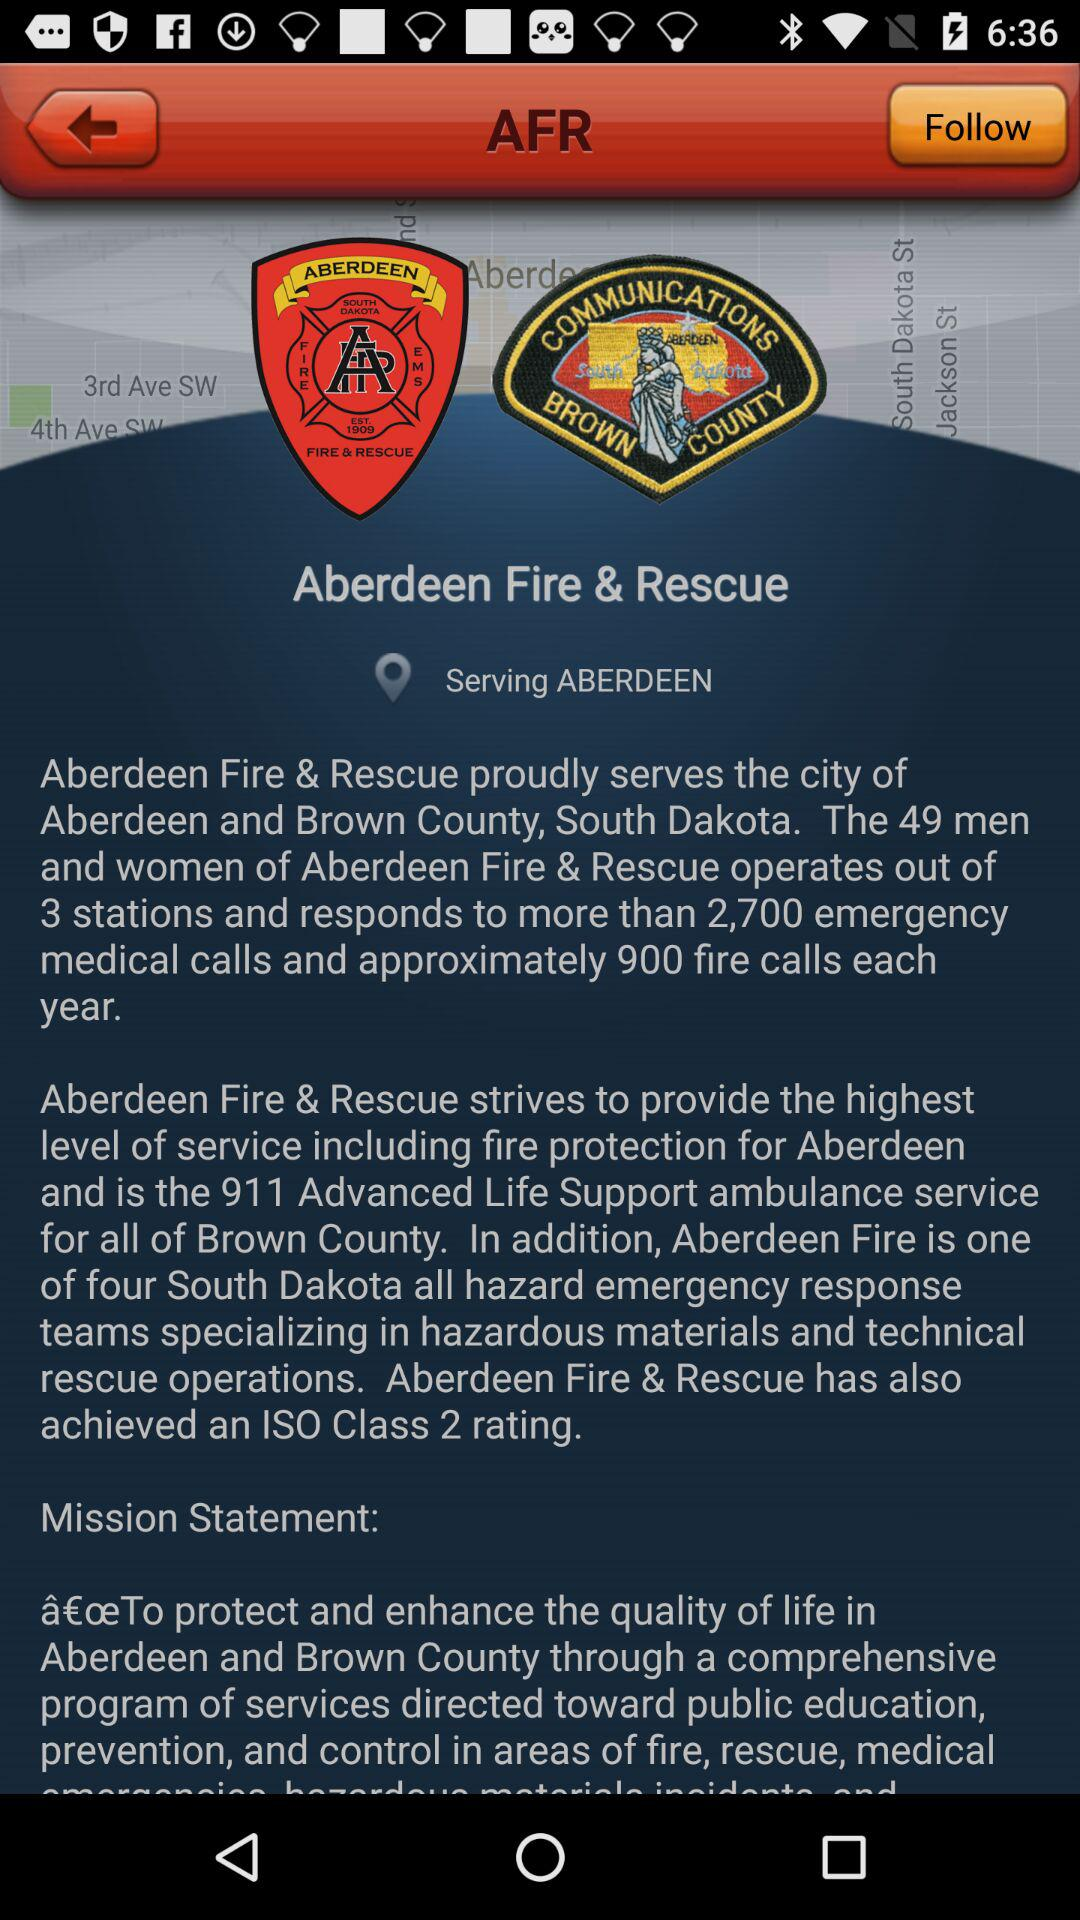How many more emergency medical calls does Aberdeen Fire & Rescue respond to than fire calls?
Answer the question using a single word or phrase. 1800 